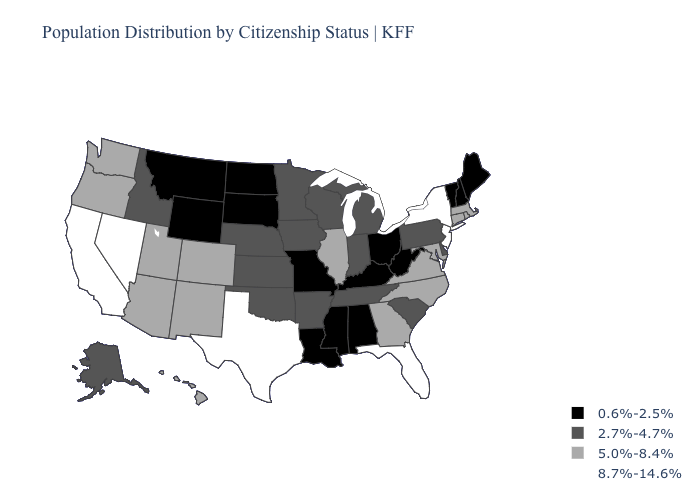Name the states that have a value in the range 5.0%-8.4%?
Short answer required. Arizona, Colorado, Connecticut, Georgia, Hawaii, Illinois, Maryland, Massachusetts, New Mexico, North Carolina, Oregon, Rhode Island, Utah, Virginia, Washington. What is the value of Iowa?
Be succinct. 2.7%-4.7%. What is the highest value in states that border Florida?
Give a very brief answer. 5.0%-8.4%. Among the states that border Colorado , which have the highest value?
Concise answer only. Arizona, New Mexico, Utah. Among the states that border Connecticut , which have the highest value?
Short answer required. New York. Does Arizona have a lower value than New Jersey?
Short answer required. Yes. How many symbols are there in the legend?
Quick response, please. 4. How many symbols are there in the legend?
Give a very brief answer. 4. Does Oregon have the same value as Iowa?
Short answer required. No. Is the legend a continuous bar?
Concise answer only. No. Does Montana have the lowest value in the West?
Quick response, please. Yes. What is the value of Massachusetts?
Keep it brief. 5.0%-8.4%. Does Illinois have the same value as Georgia?
Short answer required. Yes. Does Missouri have the lowest value in the MidWest?
Short answer required. Yes. Which states hav the highest value in the South?
Answer briefly. Florida, Texas. 